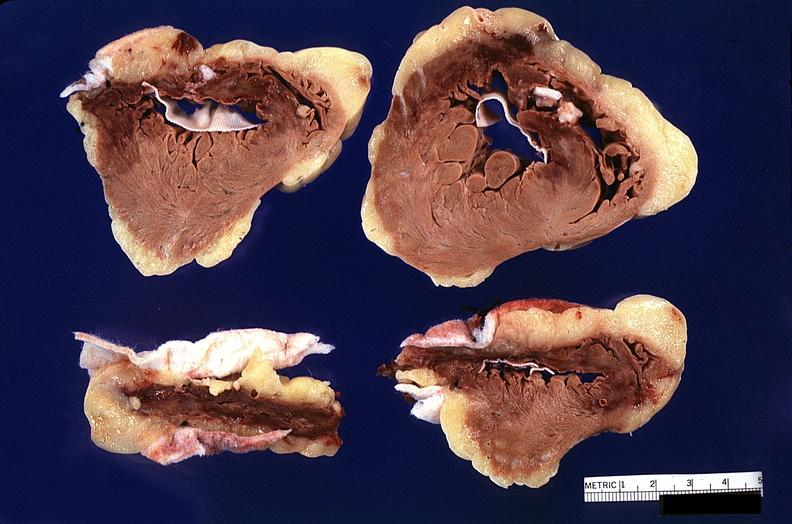does this image show heart, myocardial infarction, surgery to repair interventricular septum rupture?
Answer the question using a single word or phrase. Yes 